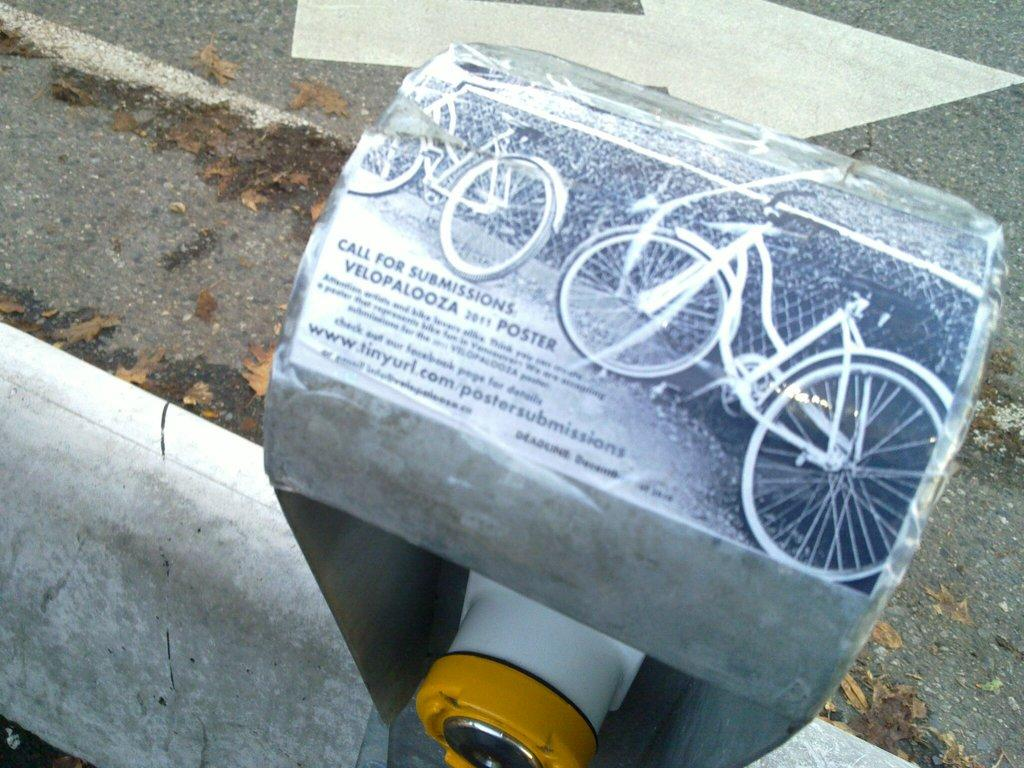What can be seen on the wall in the image? There is a poster in the image. What is located near the poster? There is a machine in the image. What directional symbol is present in the image? There is an arrow symbol in the image. What type of surface is visible in the image? There is a road in the image. What type of natural debris can be seen in the image? There are dried leaves in the image. What is written on the poster? Something is written on the poster, but the specific message cannot be determined from the image. Can you see any thoughts in the image? There are no thoughts visible in the image, as thoughts are not a physical or observable phenomenon. What type of weather condition is present in the image? The image does not provide any information about the weather, so it cannot be determined from the image. 